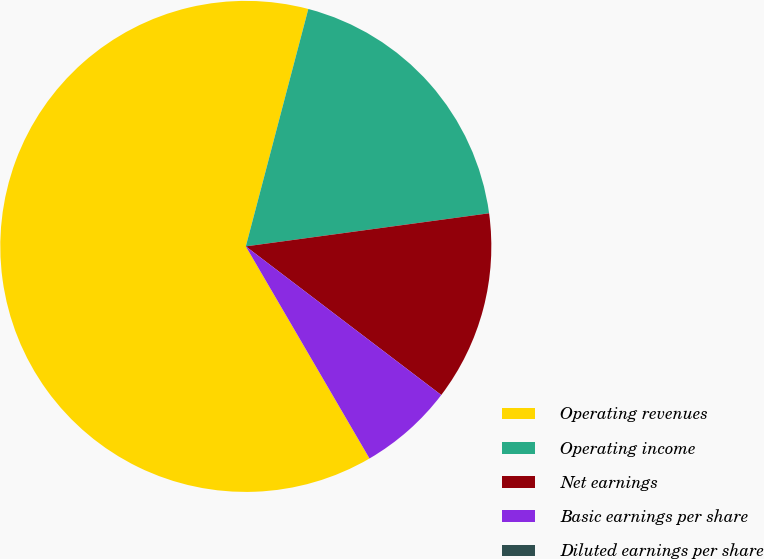<chart> <loc_0><loc_0><loc_500><loc_500><pie_chart><fcel>Operating revenues<fcel>Operating income<fcel>Net earnings<fcel>Basic earnings per share<fcel>Diluted earnings per share<nl><fcel>62.5%<fcel>18.75%<fcel>12.5%<fcel>6.25%<fcel>0.0%<nl></chart> 